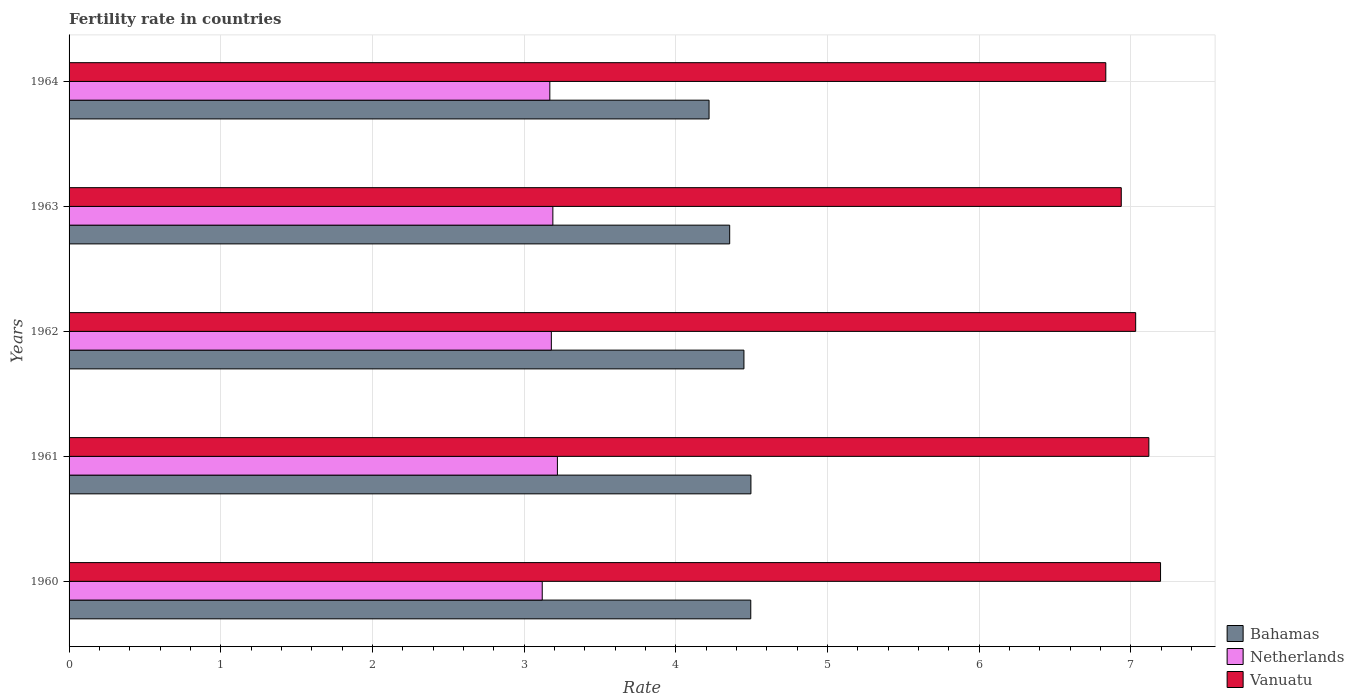How many different coloured bars are there?
Your answer should be compact. 3. How many groups of bars are there?
Offer a terse response. 5. Are the number of bars per tick equal to the number of legend labels?
Keep it short and to the point. Yes. What is the label of the 1st group of bars from the top?
Ensure brevity in your answer.  1964. What is the fertility rate in Netherlands in 1963?
Offer a terse response. 3.19. Across all years, what is the maximum fertility rate in Bahamas?
Give a very brief answer. 4.5. Across all years, what is the minimum fertility rate in Vanuatu?
Ensure brevity in your answer.  6.84. In which year was the fertility rate in Vanuatu maximum?
Provide a short and direct response. 1960. In which year was the fertility rate in Vanuatu minimum?
Ensure brevity in your answer.  1964. What is the total fertility rate in Vanuatu in the graph?
Your answer should be compact. 35.12. What is the difference between the fertility rate in Vanuatu in 1962 and that in 1964?
Make the answer very short. 0.2. What is the difference between the fertility rate in Vanuatu in 1964 and the fertility rate in Bahamas in 1963?
Make the answer very short. 2.48. What is the average fertility rate in Netherlands per year?
Your response must be concise. 3.18. In the year 1964, what is the difference between the fertility rate in Bahamas and fertility rate in Vanuatu?
Provide a succinct answer. -2.62. What is the ratio of the fertility rate in Netherlands in 1960 to that in 1962?
Provide a succinct answer. 0.98. Is the difference between the fertility rate in Bahamas in 1962 and 1964 greater than the difference between the fertility rate in Vanuatu in 1962 and 1964?
Ensure brevity in your answer.  Yes. What is the difference between the highest and the second highest fertility rate in Bahamas?
Ensure brevity in your answer.  0. What is the difference between the highest and the lowest fertility rate in Vanuatu?
Give a very brief answer. 0.36. What does the 1st bar from the top in 1963 represents?
Keep it short and to the point. Vanuatu. What does the 1st bar from the bottom in 1961 represents?
Provide a succinct answer. Bahamas. How many years are there in the graph?
Give a very brief answer. 5. Does the graph contain grids?
Your answer should be compact. Yes. Where does the legend appear in the graph?
Your response must be concise. Bottom right. How many legend labels are there?
Ensure brevity in your answer.  3. What is the title of the graph?
Make the answer very short. Fertility rate in countries. What is the label or title of the X-axis?
Your answer should be very brief. Rate. What is the label or title of the Y-axis?
Make the answer very short. Years. What is the Rate in Bahamas in 1960?
Offer a terse response. 4.5. What is the Rate of Netherlands in 1960?
Give a very brief answer. 3.12. What is the Rate of Vanuatu in 1960?
Ensure brevity in your answer.  7.2. What is the Rate of Bahamas in 1961?
Give a very brief answer. 4.5. What is the Rate of Netherlands in 1961?
Provide a short and direct response. 3.22. What is the Rate in Vanuatu in 1961?
Provide a short and direct response. 7.12. What is the Rate of Bahamas in 1962?
Give a very brief answer. 4.45. What is the Rate in Netherlands in 1962?
Offer a very short reply. 3.18. What is the Rate of Vanuatu in 1962?
Your response must be concise. 7.03. What is the Rate in Bahamas in 1963?
Keep it short and to the point. 4.36. What is the Rate in Netherlands in 1963?
Ensure brevity in your answer.  3.19. What is the Rate of Vanuatu in 1963?
Your answer should be very brief. 6.94. What is the Rate in Bahamas in 1964?
Provide a short and direct response. 4.22. What is the Rate in Netherlands in 1964?
Your answer should be compact. 3.17. What is the Rate of Vanuatu in 1964?
Keep it short and to the point. 6.84. Across all years, what is the maximum Rate in Bahamas?
Your response must be concise. 4.5. Across all years, what is the maximum Rate in Netherlands?
Provide a succinct answer. 3.22. Across all years, what is the maximum Rate of Vanuatu?
Make the answer very short. 7.2. Across all years, what is the minimum Rate of Bahamas?
Your answer should be very brief. 4.22. Across all years, what is the minimum Rate of Netherlands?
Offer a terse response. 3.12. Across all years, what is the minimum Rate of Vanuatu?
Give a very brief answer. 6.84. What is the total Rate in Bahamas in the graph?
Ensure brevity in your answer.  22.02. What is the total Rate of Netherlands in the graph?
Your response must be concise. 15.88. What is the total Rate in Vanuatu in the graph?
Your response must be concise. 35.12. What is the difference between the Rate in Bahamas in 1960 and that in 1961?
Your answer should be very brief. -0. What is the difference between the Rate in Vanuatu in 1960 and that in 1961?
Your response must be concise. 0.08. What is the difference between the Rate of Bahamas in 1960 and that in 1962?
Give a very brief answer. 0.04. What is the difference between the Rate in Netherlands in 1960 and that in 1962?
Your response must be concise. -0.06. What is the difference between the Rate in Vanuatu in 1960 and that in 1962?
Your answer should be compact. 0.16. What is the difference between the Rate in Bahamas in 1960 and that in 1963?
Offer a terse response. 0.14. What is the difference between the Rate in Netherlands in 1960 and that in 1963?
Ensure brevity in your answer.  -0.07. What is the difference between the Rate of Vanuatu in 1960 and that in 1963?
Your response must be concise. 0.26. What is the difference between the Rate of Bahamas in 1960 and that in 1964?
Your answer should be compact. 0.28. What is the difference between the Rate in Netherlands in 1960 and that in 1964?
Keep it short and to the point. -0.05. What is the difference between the Rate of Vanuatu in 1960 and that in 1964?
Your response must be concise. 0.36. What is the difference between the Rate in Bahamas in 1961 and that in 1962?
Your answer should be very brief. 0.05. What is the difference between the Rate of Netherlands in 1961 and that in 1962?
Give a very brief answer. 0.04. What is the difference between the Rate in Vanuatu in 1961 and that in 1962?
Offer a terse response. 0.09. What is the difference between the Rate of Bahamas in 1961 and that in 1963?
Make the answer very short. 0.14. What is the difference between the Rate of Vanuatu in 1961 and that in 1963?
Ensure brevity in your answer.  0.18. What is the difference between the Rate of Bahamas in 1961 and that in 1964?
Provide a short and direct response. 0.28. What is the difference between the Rate in Netherlands in 1961 and that in 1964?
Make the answer very short. 0.05. What is the difference between the Rate of Vanuatu in 1961 and that in 1964?
Ensure brevity in your answer.  0.28. What is the difference between the Rate of Bahamas in 1962 and that in 1963?
Your answer should be very brief. 0.09. What is the difference between the Rate of Netherlands in 1962 and that in 1963?
Give a very brief answer. -0.01. What is the difference between the Rate of Vanuatu in 1962 and that in 1963?
Give a very brief answer. 0.1. What is the difference between the Rate in Bahamas in 1962 and that in 1964?
Make the answer very short. 0.23. What is the difference between the Rate of Netherlands in 1962 and that in 1964?
Provide a succinct answer. 0.01. What is the difference between the Rate of Vanuatu in 1962 and that in 1964?
Your answer should be very brief. 0.2. What is the difference between the Rate in Bahamas in 1963 and that in 1964?
Keep it short and to the point. 0.14. What is the difference between the Rate in Netherlands in 1963 and that in 1964?
Ensure brevity in your answer.  0.02. What is the difference between the Rate of Vanuatu in 1963 and that in 1964?
Provide a succinct answer. 0.1. What is the difference between the Rate in Bahamas in 1960 and the Rate in Netherlands in 1961?
Your answer should be very brief. 1.27. What is the difference between the Rate of Bahamas in 1960 and the Rate of Vanuatu in 1961?
Provide a succinct answer. -2.62. What is the difference between the Rate in Netherlands in 1960 and the Rate in Vanuatu in 1961?
Offer a terse response. -4. What is the difference between the Rate of Bahamas in 1960 and the Rate of Netherlands in 1962?
Provide a succinct answer. 1.31. What is the difference between the Rate in Bahamas in 1960 and the Rate in Vanuatu in 1962?
Offer a very short reply. -2.54. What is the difference between the Rate in Netherlands in 1960 and the Rate in Vanuatu in 1962?
Your response must be concise. -3.91. What is the difference between the Rate of Bahamas in 1960 and the Rate of Netherlands in 1963?
Your answer should be compact. 1.3. What is the difference between the Rate of Bahamas in 1960 and the Rate of Vanuatu in 1963?
Your answer should be very brief. -2.44. What is the difference between the Rate of Netherlands in 1960 and the Rate of Vanuatu in 1963?
Make the answer very short. -3.82. What is the difference between the Rate in Bahamas in 1960 and the Rate in Netherlands in 1964?
Your answer should be very brief. 1.32. What is the difference between the Rate of Bahamas in 1960 and the Rate of Vanuatu in 1964?
Provide a succinct answer. -2.34. What is the difference between the Rate in Netherlands in 1960 and the Rate in Vanuatu in 1964?
Keep it short and to the point. -3.72. What is the difference between the Rate of Bahamas in 1961 and the Rate of Netherlands in 1962?
Provide a succinct answer. 1.32. What is the difference between the Rate of Bahamas in 1961 and the Rate of Vanuatu in 1962?
Your answer should be very brief. -2.54. What is the difference between the Rate in Netherlands in 1961 and the Rate in Vanuatu in 1962?
Keep it short and to the point. -3.81. What is the difference between the Rate of Bahamas in 1961 and the Rate of Netherlands in 1963?
Your response must be concise. 1.31. What is the difference between the Rate of Bahamas in 1961 and the Rate of Vanuatu in 1963?
Provide a short and direct response. -2.44. What is the difference between the Rate of Netherlands in 1961 and the Rate of Vanuatu in 1963?
Provide a short and direct response. -3.72. What is the difference between the Rate in Bahamas in 1961 and the Rate in Netherlands in 1964?
Provide a short and direct response. 1.33. What is the difference between the Rate in Bahamas in 1961 and the Rate in Vanuatu in 1964?
Keep it short and to the point. -2.34. What is the difference between the Rate of Netherlands in 1961 and the Rate of Vanuatu in 1964?
Offer a very short reply. -3.62. What is the difference between the Rate of Bahamas in 1962 and the Rate of Netherlands in 1963?
Ensure brevity in your answer.  1.26. What is the difference between the Rate in Bahamas in 1962 and the Rate in Vanuatu in 1963?
Give a very brief answer. -2.49. What is the difference between the Rate of Netherlands in 1962 and the Rate of Vanuatu in 1963?
Provide a succinct answer. -3.76. What is the difference between the Rate of Bahamas in 1962 and the Rate of Netherlands in 1964?
Offer a very short reply. 1.28. What is the difference between the Rate in Bahamas in 1962 and the Rate in Vanuatu in 1964?
Ensure brevity in your answer.  -2.39. What is the difference between the Rate in Netherlands in 1962 and the Rate in Vanuatu in 1964?
Your response must be concise. -3.66. What is the difference between the Rate of Bahamas in 1963 and the Rate of Netherlands in 1964?
Give a very brief answer. 1.19. What is the difference between the Rate in Bahamas in 1963 and the Rate in Vanuatu in 1964?
Offer a very short reply. -2.48. What is the difference between the Rate in Netherlands in 1963 and the Rate in Vanuatu in 1964?
Your response must be concise. -3.65. What is the average Rate of Bahamas per year?
Ensure brevity in your answer.  4.4. What is the average Rate of Netherlands per year?
Offer a very short reply. 3.18. What is the average Rate in Vanuatu per year?
Keep it short and to the point. 7.02. In the year 1960, what is the difference between the Rate in Bahamas and Rate in Netherlands?
Your answer should be compact. 1.38. In the year 1960, what is the difference between the Rate of Bahamas and Rate of Vanuatu?
Keep it short and to the point. -2.7. In the year 1960, what is the difference between the Rate of Netherlands and Rate of Vanuatu?
Provide a succinct answer. -4.08. In the year 1961, what is the difference between the Rate of Bahamas and Rate of Netherlands?
Provide a short and direct response. 1.28. In the year 1961, what is the difference between the Rate of Bahamas and Rate of Vanuatu?
Provide a succinct answer. -2.62. In the year 1961, what is the difference between the Rate in Netherlands and Rate in Vanuatu?
Make the answer very short. -3.9. In the year 1962, what is the difference between the Rate of Bahamas and Rate of Netherlands?
Provide a succinct answer. 1.27. In the year 1962, what is the difference between the Rate of Bahamas and Rate of Vanuatu?
Offer a terse response. -2.58. In the year 1962, what is the difference between the Rate in Netherlands and Rate in Vanuatu?
Keep it short and to the point. -3.85. In the year 1963, what is the difference between the Rate of Bahamas and Rate of Netherlands?
Your response must be concise. 1.17. In the year 1963, what is the difference between the Rate in Bahamas and Rate in Vanuatu?
Offer a terse response. -2.58. In the year 1963, what is the difference between the Rate in Netherlands and Rate in Vanuatu?
Your answer should be very brief. -3.75. In the year 1964, what is the difference between the Rate in Bahamas and Rate in Vanuatu?
Give a very brief answer. -2.62. In the year 1964, what is the difference between the Rate of Netherlands and Rate of Vanuatu?
Provide a short and direct response. -3.67. What is the ratio of the Rate in Netherlands in 1960 to that in 1961?
Ensure brevity in your answer.  0.97. What is the ratio of the Rate of Vanuatu in 1960 to that in 1961?
Provide a short and direct response. 1.01. What is the ratio of the Rate of Bahamas in 1960 to that in 1962?
Provide a succinct answer. 1.01. What is the ratio of the Rate of Netherlands in 1960 to that in 1962?
Offer a terse response. 0.98. What is the ratio of the Rate of Vanuatu in 1960 to that in 1962?
Your answer should be compact. 1.02. What is the ratio of the Rate of Bahamas in 1960 to that in 1963?
Your answer should be very brief. 1.03. What is the ratio of the Rate in Netherlands in 1960 to that in 1963?
Make the answer very short. 0.98. What is the ratio of the Rate in Vanuatu in 1960 to that in 1963?
Keep it short and to the point. 1.04. What is the ratio of the Rate in Bahamas in 1960 to that in 1964?
Make the answer very short. 1.07. What is the ratio of the Rate of Netherlands in 1960 to that in 1964?
Your answer should be very brief. 0.98. What is the ratio of the Rate of Vanuatu in 1960 to that in 1964?
Offer a very short reply. 1.05. What is the ratio of the Rate of Bahamas in 1961 to that in 1962?
Keep it short and to the point. 1.01. What is the ratio of the Rate of Netherlands in 1961 to that in 1962?
Your answer should be compact. 1.01. What is the ratio of the Rate in Vanuatu in 1961 to that in 1962?
Your response must be concise. 1.01. What is the ratio of the Rate of Bahamas in 1961 to that in 1963?
Keep it short and to the point. 1.03. What is the ratio of the Rate of Netherlands in 1961 to that in 1963?
Make the answer very short. 1.01. What is the ratio of the Rate in Vanuatu in 1961 to that in 1963?
Your answer should be very brief. 1.03. What is the ratio of the Rate of Bahamas in 1961 to that in 1964?
Keep it short and to the point. 1.07. What is the ratio of the Rate of Netherlands in 1961 to that in 1964?
Provide a short and direct response. 1.02. What is the ratio of the Rate of Vanuatu in 1961 to that in 1964?
Your response must be concise. 1.04. What is the ratio of the Rate in Bahamas in 1962 to that in 1963?
Ensure brevity in your answer.  1.02. What is the ratio of the Rate in Netherlands in 1962 to that in 1963?
Ensure brevity in your answer.  1. What is the ratio of the Rate in Vanuatu in 1962 to that in 1963?
Offer a terse response. 1.01. What is the ratio of the Rate in Bahamas in 1962 to that in 1964?
Offer a terse response. 1.05. What is the ratio of the Rate of Netherlands in 1962 to that in 1964?
Your response must be concise. 1. What is the ratio of the Rate in Vanuatu in 1962 to that in 1964?
Ensure brevity in your answer.  1.03. What is the ratio of the Rate in Bahamas in 1963 to that in 1964?
Ensure brevity in your answer.  1.03. What is the ratio of the Rate in Netherlands in 1963 to that in 1964?
Offer a terse response. 1.01. What is the ratio of the Rate in Vanuatu in 1963 to that in 1964?
Provide a short and direct response. 1.01. What is the difference between the highest and the second highest Rate of Bahamas?
Keep it short and to the point. 0. What is the difference between the highest and the second highest Rate in Netherlands?
Provide a short and direct response. 0.03. What is the difference between the highest and the second highest Rate in Vanuatu?
Your response must be concise. 0.08. What is the difference between the highest and the lowest Rate of Bahamas?
Your answer should be compact. 0.28. What is the difference between the highest and the lowest Rate of Vanuatu?
Your answer should be very brief. 0.36. 